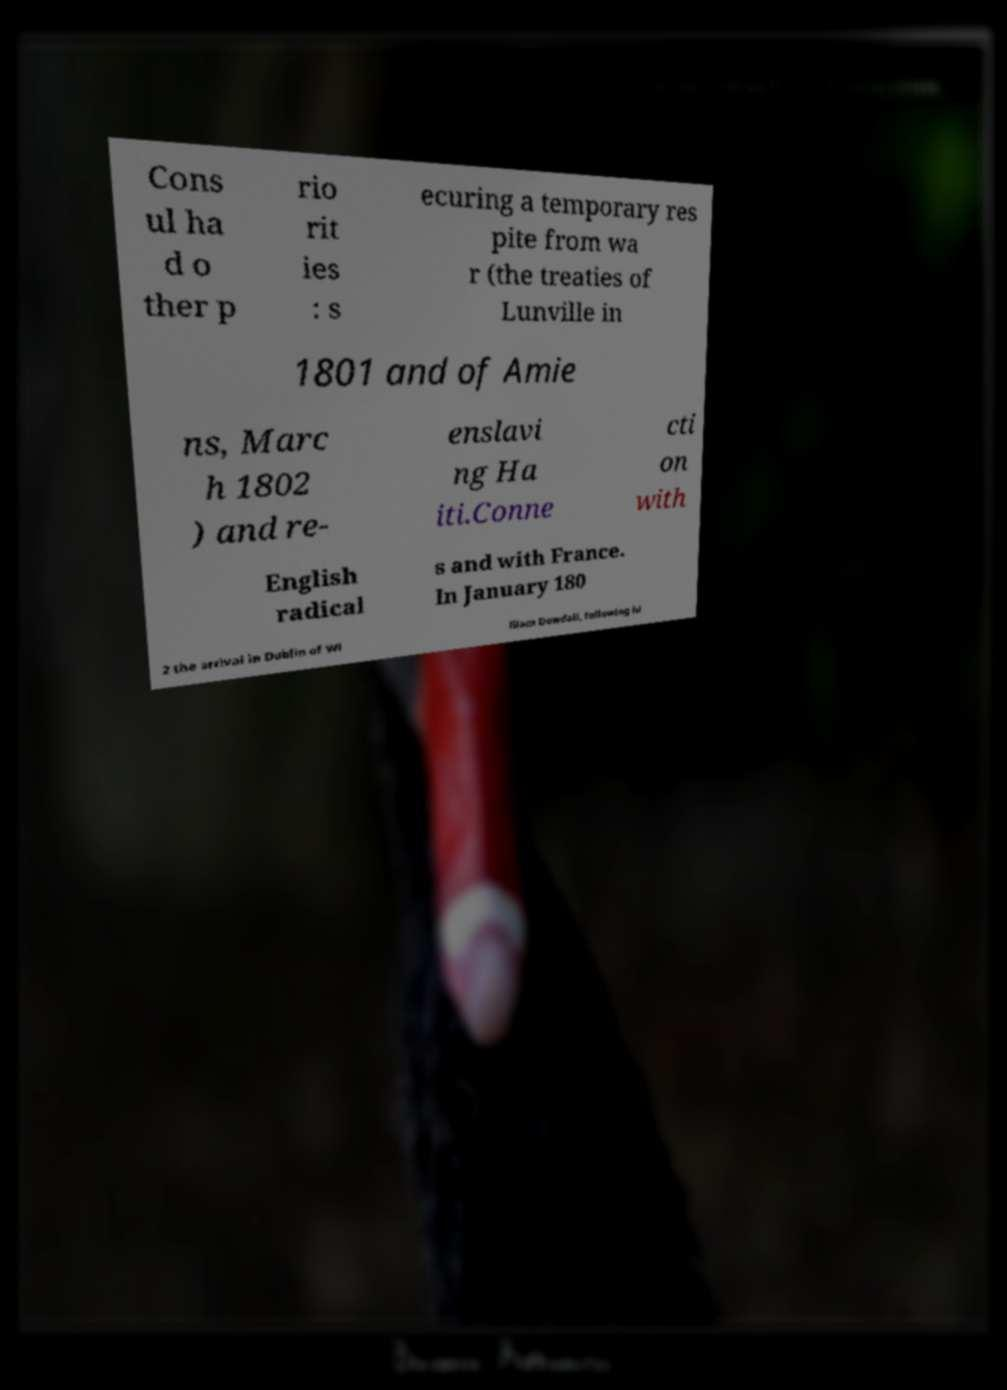Can you read and provide the text displayed in the image?This photo seems to have some interesting text. Can you extract and type it out for me? Cons ul ha d o ther p rio rit ies : s ecuring a temporary res pite from wa r (the treaties of Lunville in 1801 and of Amie ns, Marc h 1802 ) and re- enslavi ng Ha iti.Conne cti on with English radical s and with France. In January 180 2 the arrival in Dublin of Wi lliam Dowdall, following hi 